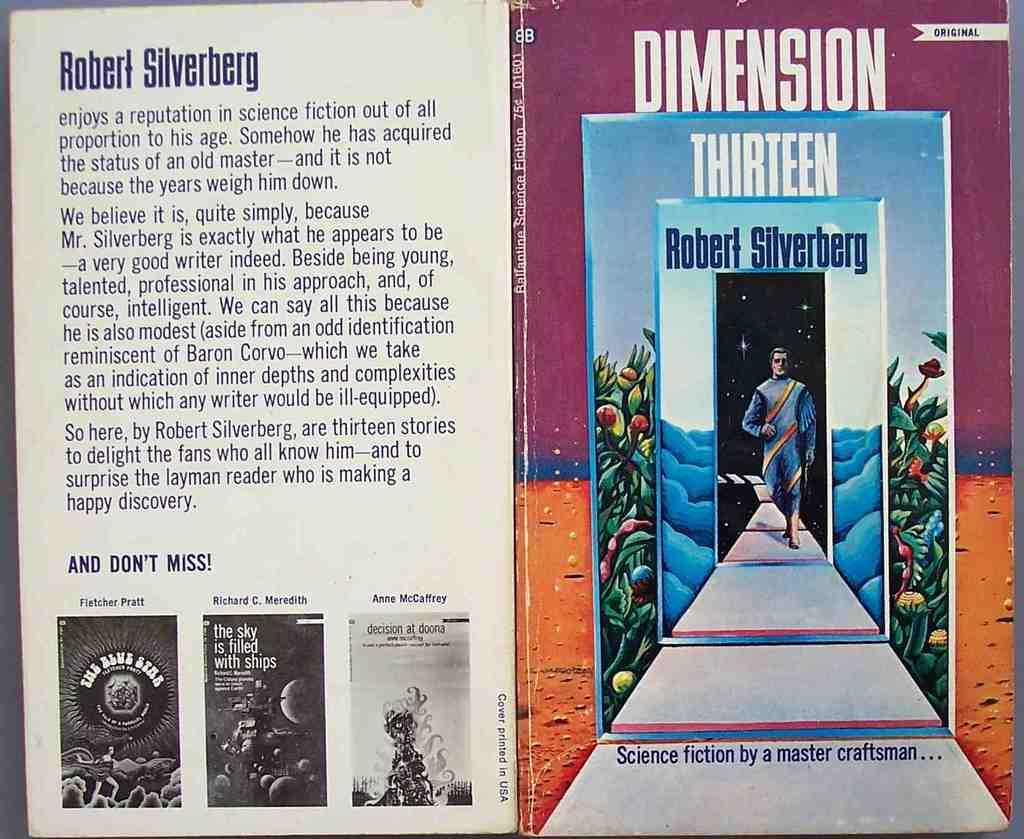<image>
Give a short and clear explanation of the subsequent image. A book cover called Dimension Thirteen by Robert Silverberg. 